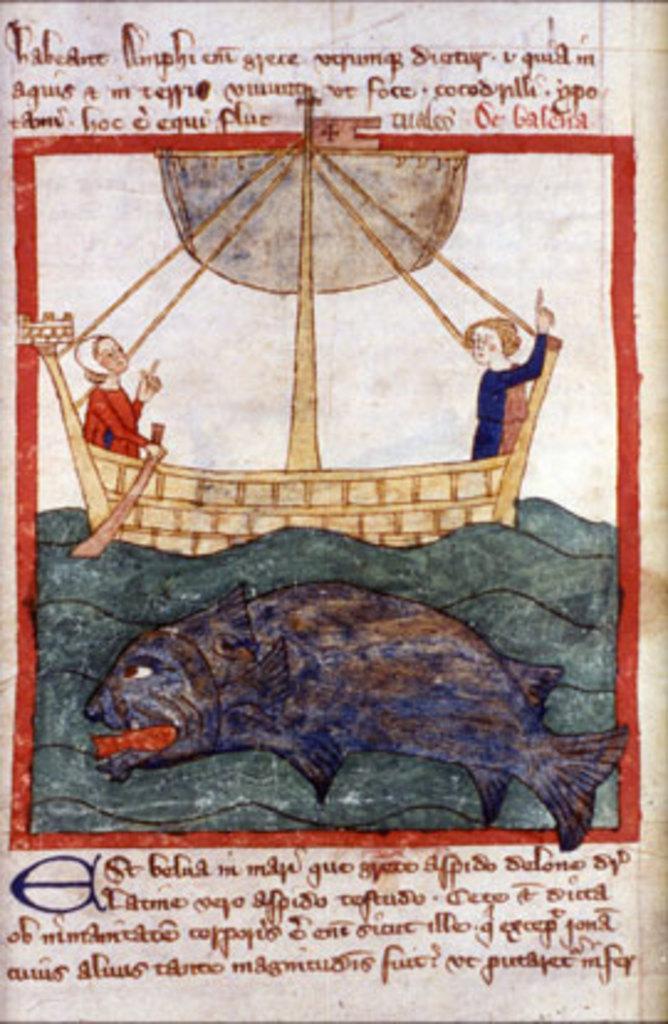Please provide a concise description of this image. Here in this picture we can see an image and some text printed on a paper. 